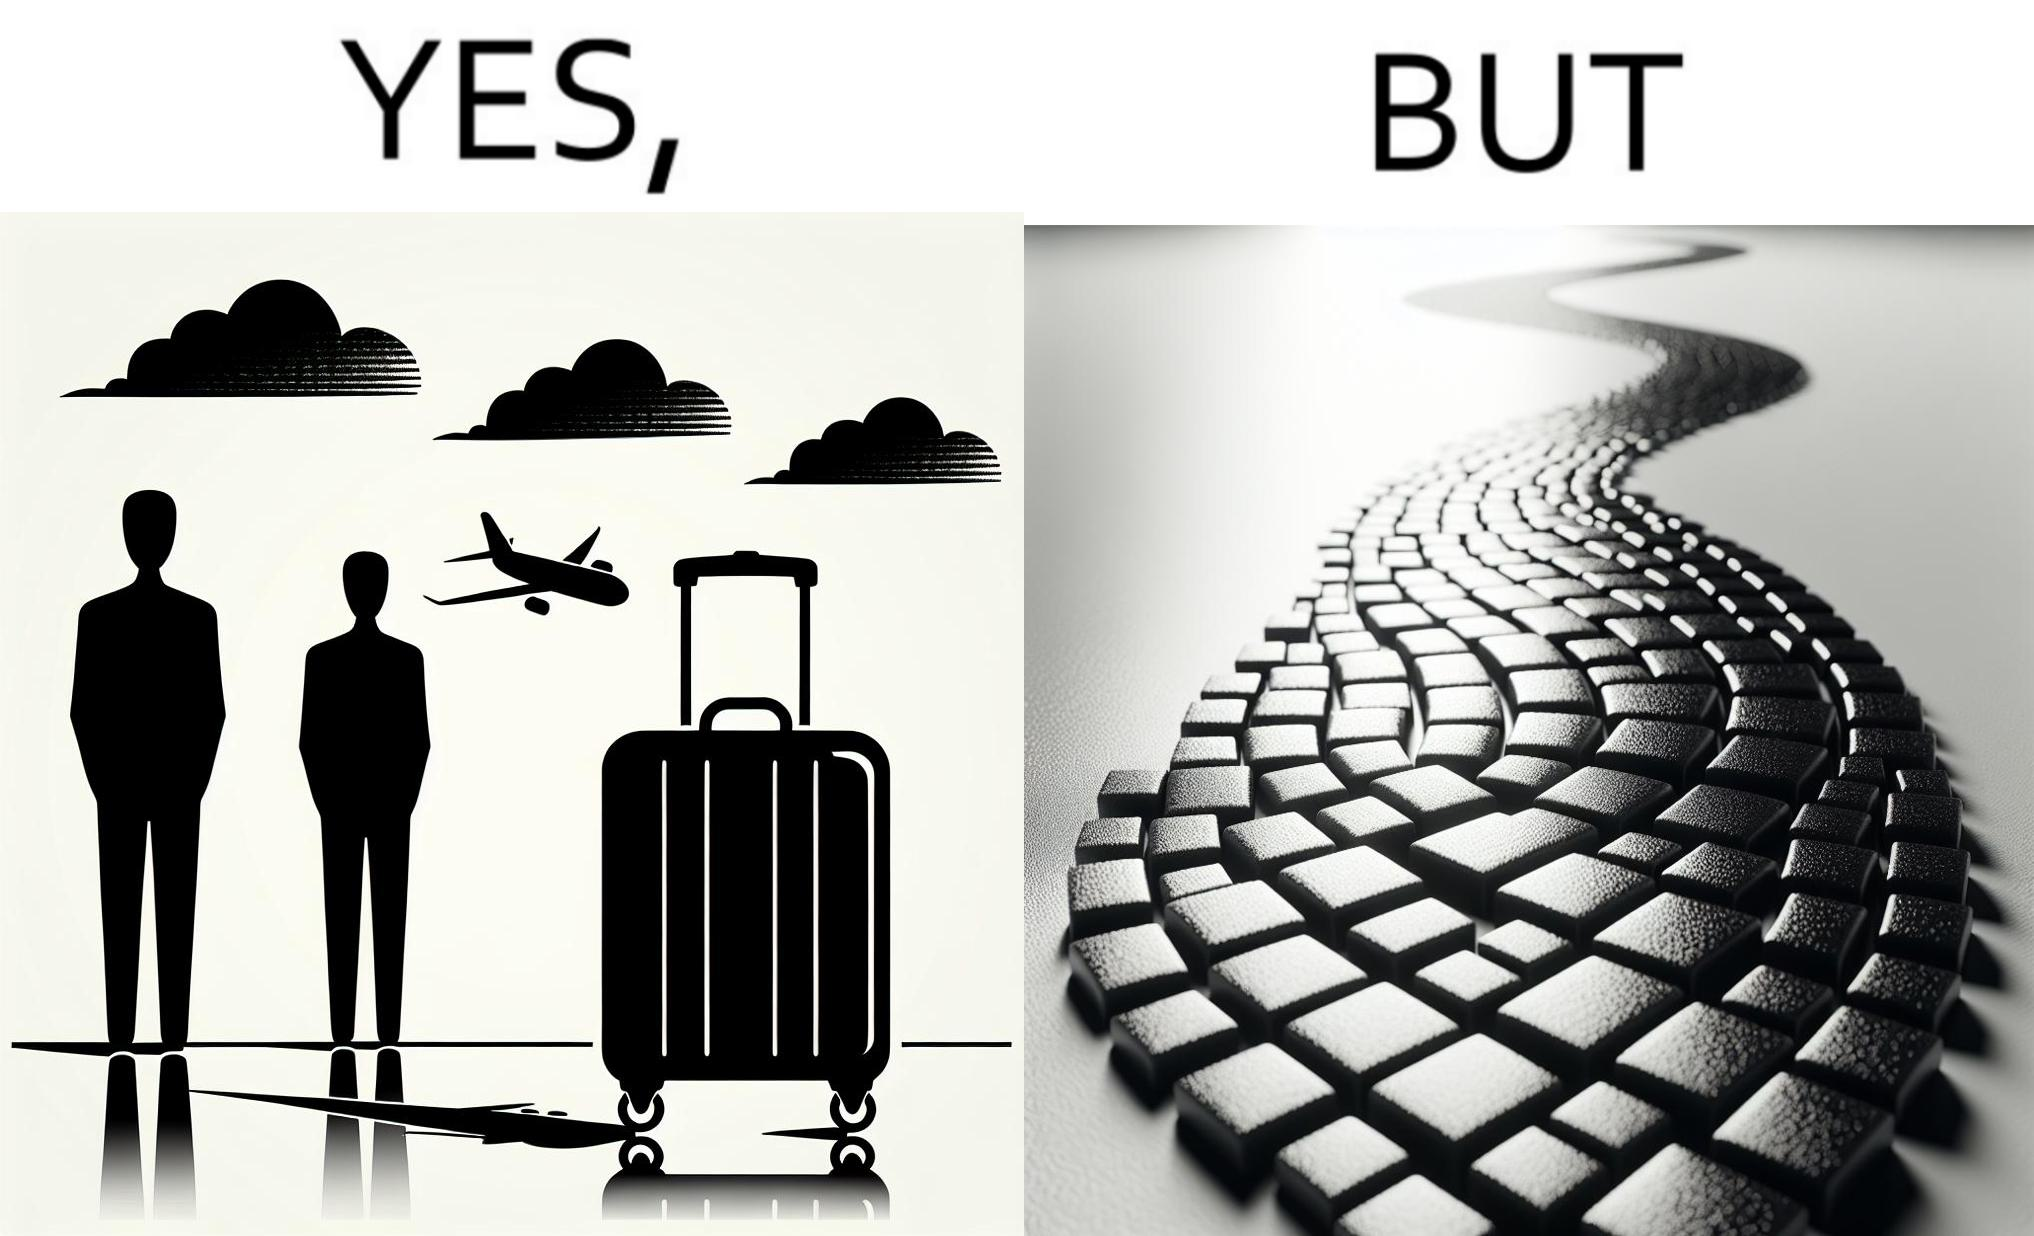What is shown in this image? The image is funny because even though the trolley bag is made to make carrying luggage easy, as soon as it encounters a rough surface like cobblestone road, it makes carrying luggage more difficult. 